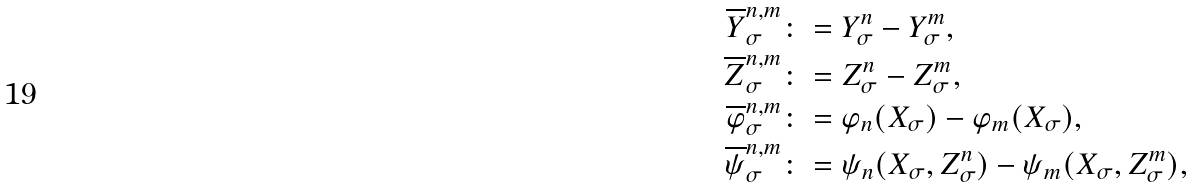<formula> <loc_0><loc_0><loc_500><loc_500>\overline { Y } ^ { n , m } _ { \sigma } & \colon = Y ^ { n } _ { \sigma } - Y ^ { m } _ { \sigma } , \\ \overline { Z } ^ { n , m } _ { \sigma } & \colon = Z ^ { n } _ { \sigma } - Z ^ { m } _ { \sigma } , \\ \overline { \varphi } ^ { n , m } _ { \sigma } & \colon = \varphi _ { n } ( X _ { \sigma } ) - \varphi _ { m } ( X _ { \sigma } ) , \\ \overline { \psi } ^ { n , m } _ { \sigma } & \colon = \psi _ { n } ( X _ { \sigma } , Z ^ { n } _ { \sigma } ) - \psi _ { m } ( X _ { \sigma } , Z ^ { m } _ { \sigma } ) ,</formula> 